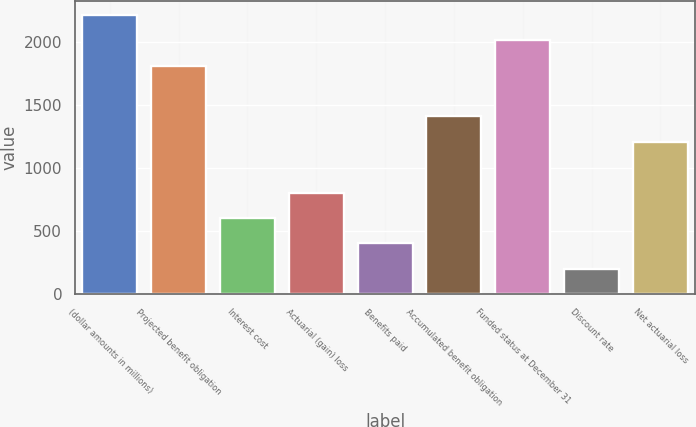Convert chart. <chart><loc_0><loc_0><loc_500><loc_500><bar_chart><fcel>(dollar amounts in millions)<fcel>Projected benefit obligation<fcel>Interest cost<fcel>Actuarial (gain) loss<fcel>Benefits paid<fcel>Accumulated benefit obligation<fcel>Funded status at December 31<fcel>Discount rate<fcel>Net actuarial loss<nl><fcel>2213<fcel>1811<fcel>605<fcel>806<fcel>404<fcel>1409<fcel>2012<fcel>203<fcel>1208<nl></chart> 